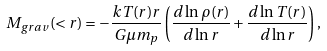<formula> <loc_0><loc_0><loc_500><loc_500>M _ { g r a v } ( < r ) = - \frac { k T ( r ) r } { G \mu m _ { p } } \left ( \frac { d \ln { \rho ( r ) } } { d \ln { r } } + \frac { d \ln { T ( r ) } } { d \ln { r } } \right ) ,</formula> 